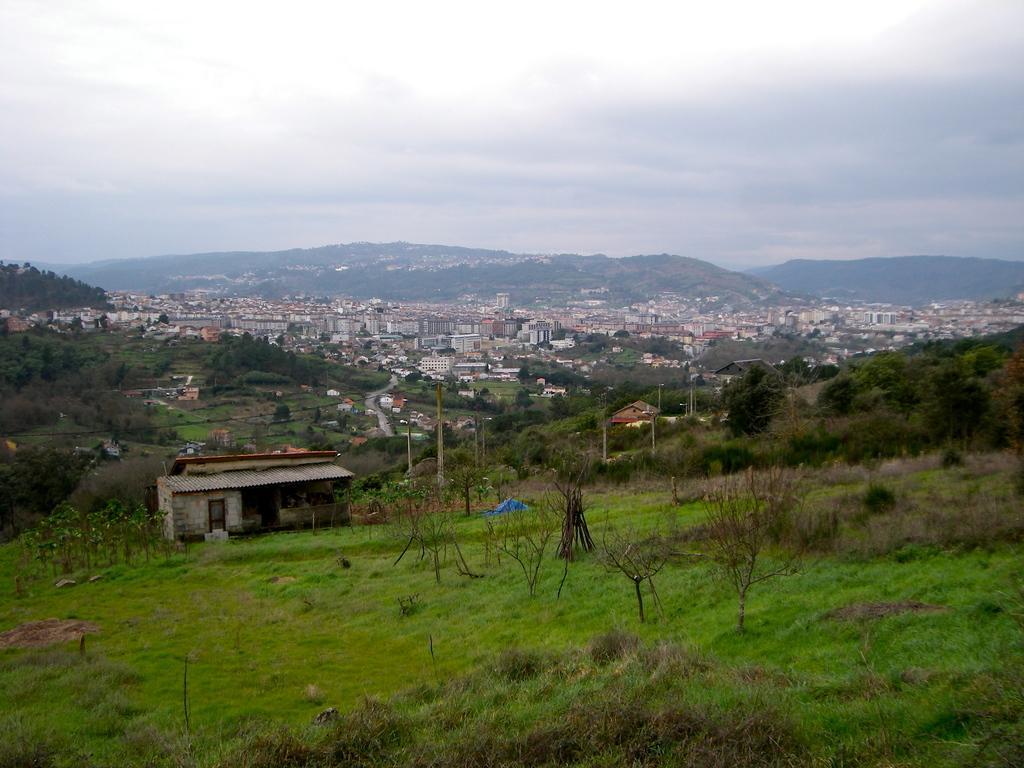Describe this image in one or two sentences. This image consists of so many buildings in the middle. This image is taken from a hilly area. There is grass in this image. There are trees in the middle. There is sky at the top. 